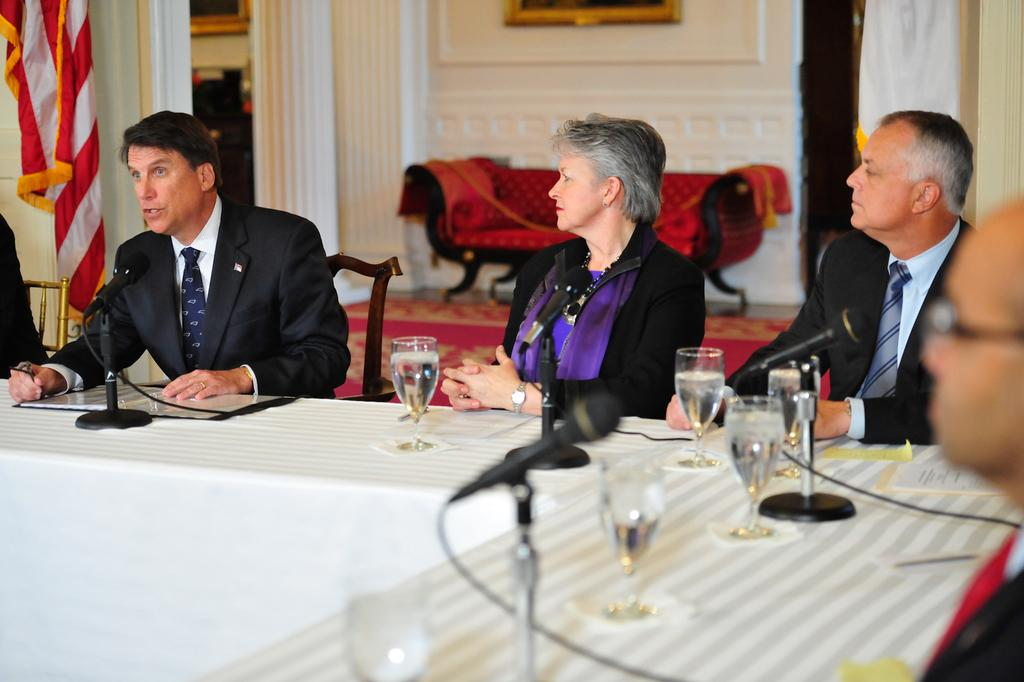What are the people in the image doing? There are persons sitting in the image, which suggests they might be engaged in an activity or conversation. What is on the table in the image? There are glasses and mics on the table. Can you describe the background of the image? There is a chair and a wall in the background of the image. What type of calculator is being used by the person in the image? There is no calculator present in the image. Can you hear any thunder in the image? There is no sound or indication of thunder in the image. 